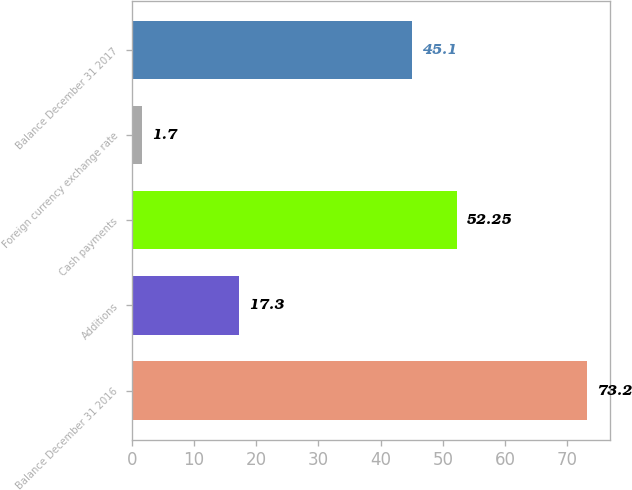Convert chart. <chart><loc_0><loc_0><loc_500><loc_500><bar_chart><fcel>Balance December 31 2016<fcel>Additions<fcel>Cash payments<fcel>Foreign currency exchange rate<fcel>Balance December 31 2017<nl><fcel>73.2<fcel>17.3<fcel>52.25<fcel>1.7<fcel>45.1<nl></chart> 